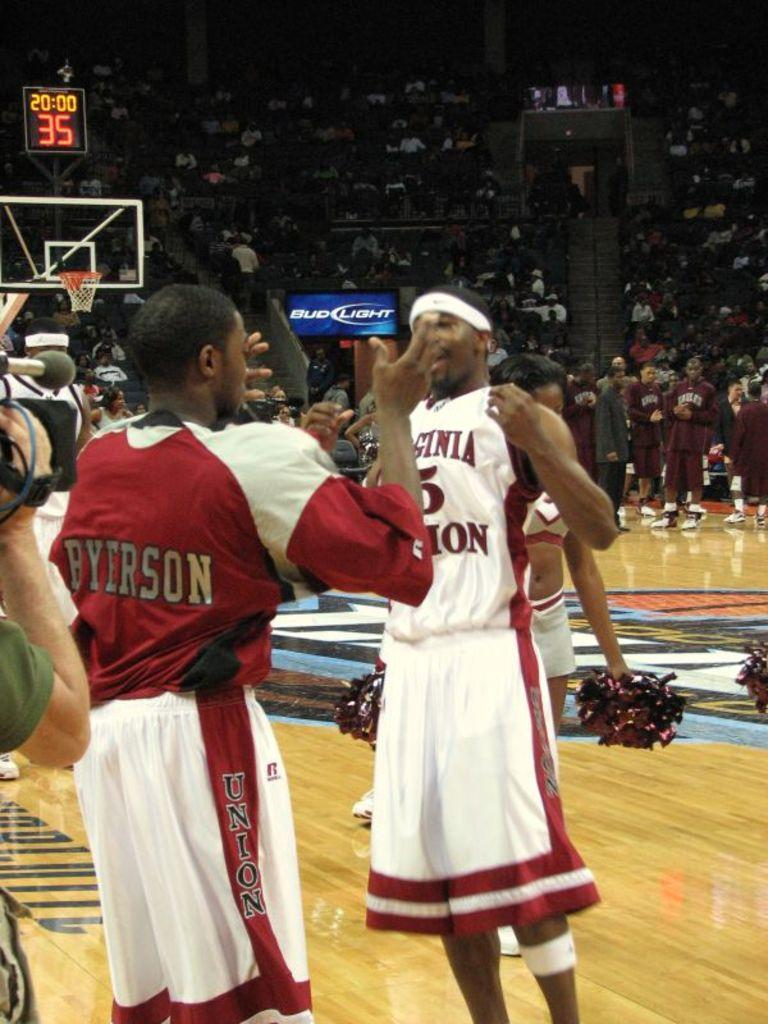Provide a one-sentence caption for the provided image. Byerson is interacting with a Virginia basketball player. 